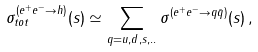<formula> <loc_0><loc_0><loc_500><loc_500>\sigma _ { t o t } ^ { ( e ^ { + } e ^ { - } \to h ) } ( s ) \simeq \sum _ { q = u , d , s , . . } \sigma ^ { ( e ^ { + } e ^ { - } \to q \bar { q } ) } ( s ) \, ,</formula> 